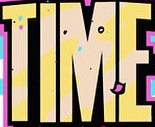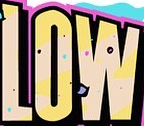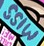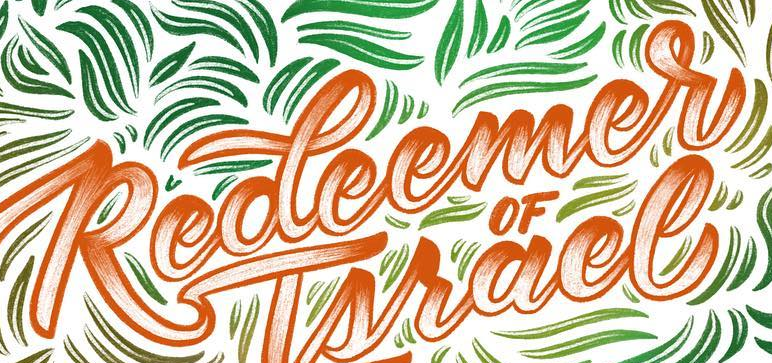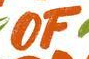Read the text from these images in sequence, separated by a semicolon. TIME; LOW; MISS; Redeemer; OF 